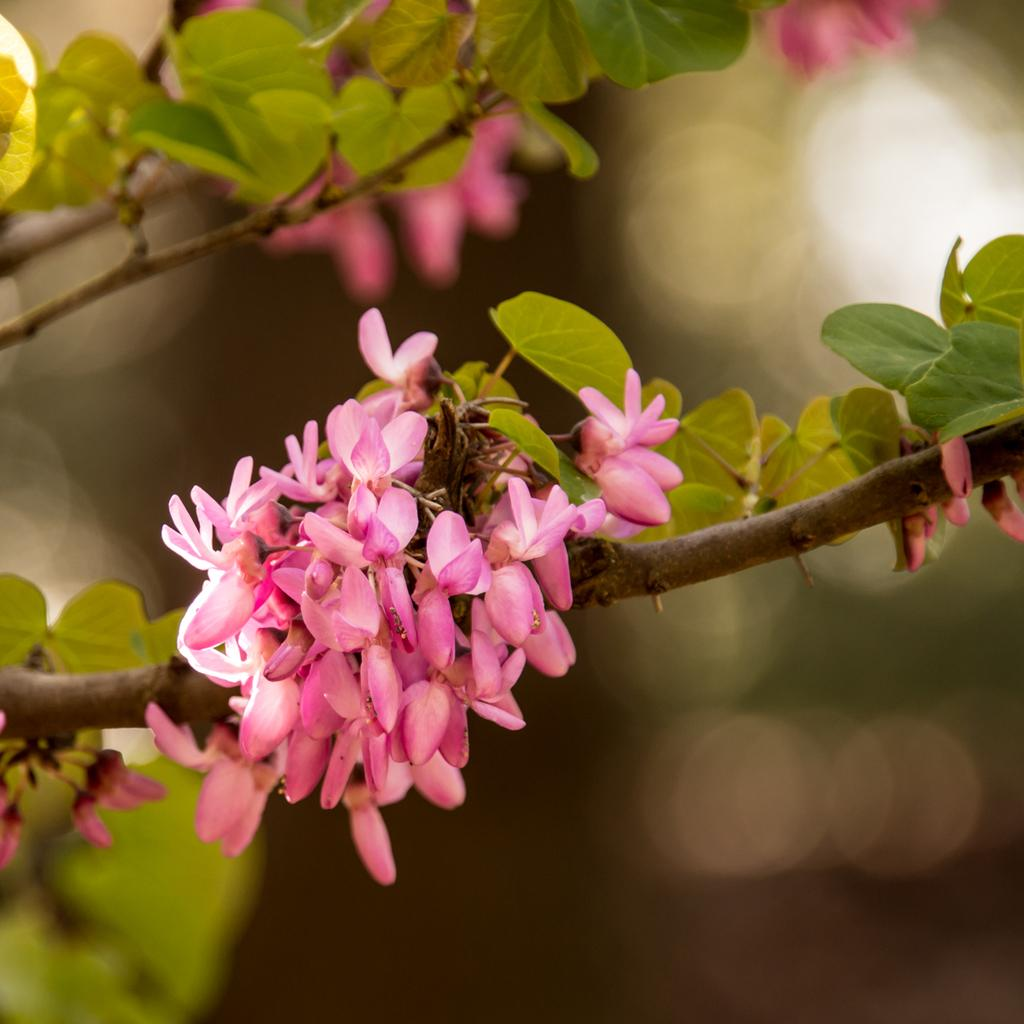What is located on the left side of the image? There are branches of a tree on the left side of the image. What can be observed on the branches? The branches have leaves and flowers. How would you describe the background of the image? The background of the image is blurred. In what direction are the branches of the tree leaning in the image? The provided facts do not mention the direction in which the branches are leaning, so it cannot be determined from the image. 